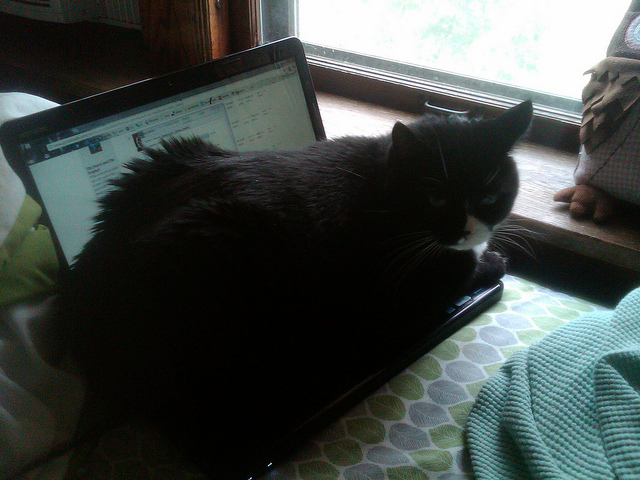What might this cat be watching so intently? The cat is likely observing something that has caught its attention outside the window, possibly small birds or moving vehicles. Cats are naturally curious and have a strong predatory instinct that draws their interest to movement. 